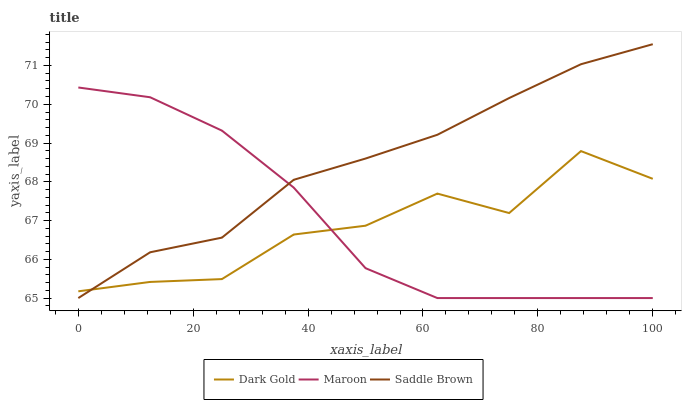Does Dark Gold have the minimum area under the curve?
Answer yes or no. Yes. Does Saddle Brown have the maximum area under the curve?
Answer yes or no. Yes. Does Maroon have the minimum area under the curve?
Answer yes or no. No. Does Maroon have the maximum area under the curve?
Answer yes or no. No. Is Saddle Brown the smoothest?
Answer yes or no. Yes. Is Dark Gold the roughest?
Answer yes or no. Yes. Is Maroon the smoothest?
Answer yes or no. No. Is Maroon the roughest?
Answer yes or no. No. Does Saddle Brown have the lowest value?
Answer yes or no. Yes. Does Dark Gold have the lowest value?
Answer yes or no. No. Does Saddle Brown have the highest value?
Answer yes or no. Yes. Does Maroon have the highest value?
Answer yes or no. No. Does Saddle Brown intersect Maroon?
Answer yes or no. Yes. Is Saddle Brown less than Maroon?
Answer yes or no. No. Is Saddle Brown greater than Maroon?
Answer yes or no. No. 